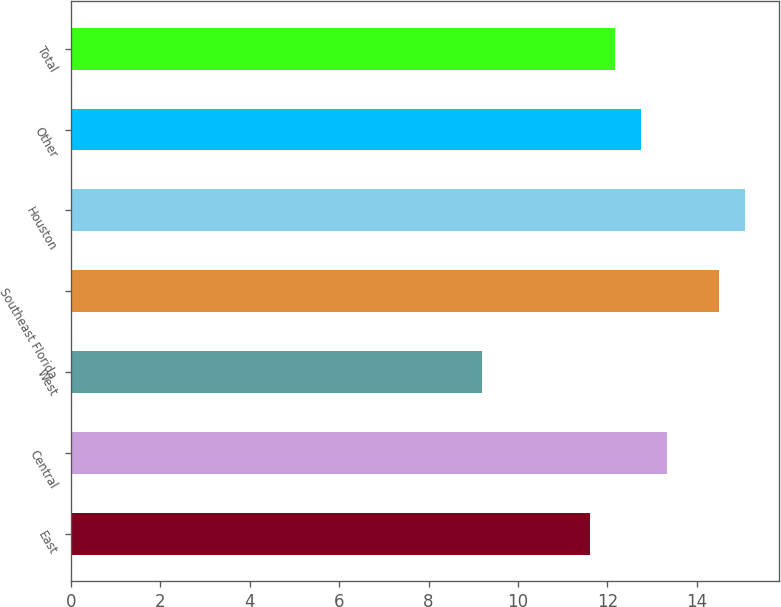Convert chart. <chart><loc_0><loc_0><loc_500><loc_500><bar_chart><fcel>East<fcel>Central<fcel>West<fcel>Southeast Florida<fcel>Houston<fcel>Other<fcel>Total<nl><fcel>11.6<fcel>13.34<fcel>9.2<fcel>14.5<fcel>15.08<fcel>12.76<fcel>12.18<nl></chart> 